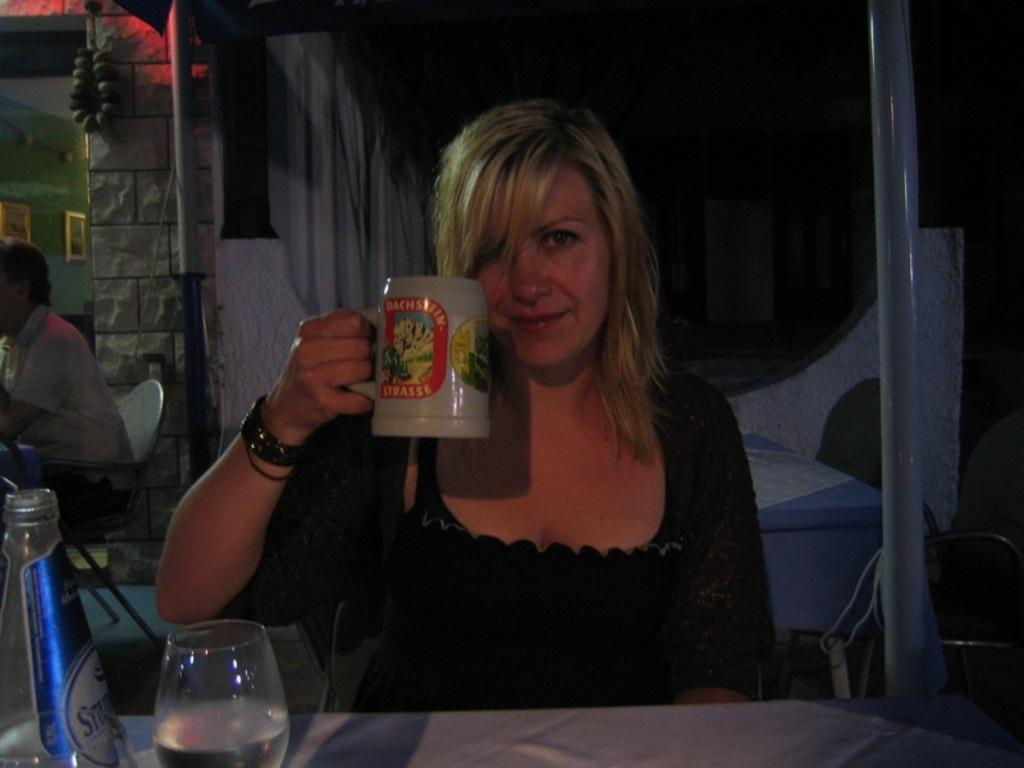How many people are in the image? There are two persons in the image. What is the woman holding in the image? The woman is holding a cup. What can be seen in the background of the image? There is a wall in the background of the image. What is attached to the wall in the background? Frames are attached to the wall in the background. How much profit did the crowd generate from sorting the frames in the image? There is no crowd, sorting activity, or profit mentioned in the image. The image only features two persons, one of whom is holding a cup, and a wall with frames attached to it. 